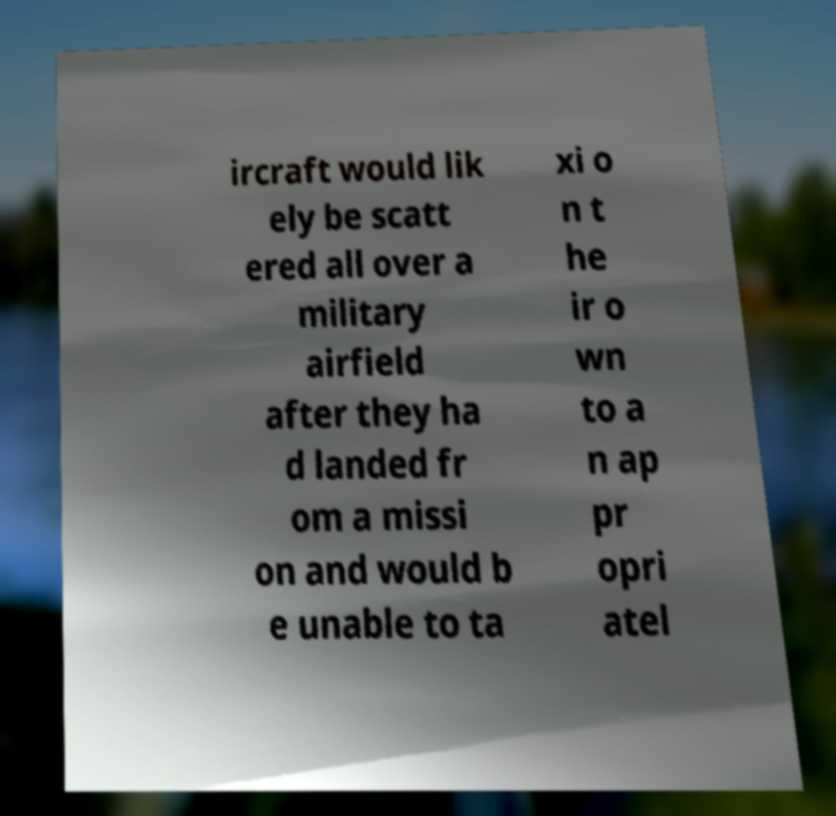Can you accurately transcribe the text from the provided image for me? ircraft would lik ely be scatt ered all over a military airfield after they ha d landed fr om a missi on and would b e unable to ta xi o n t he ir o wn to a n ap pr opri atel 